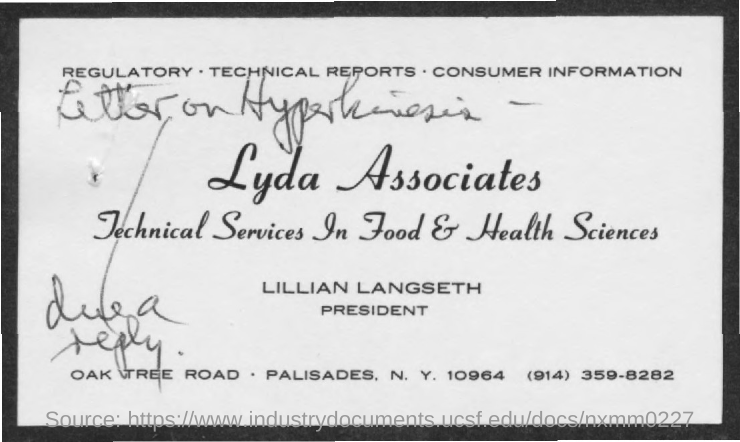Who is the president of Lyda Associates?
Provide a succinct answer. Lillian langseth. 